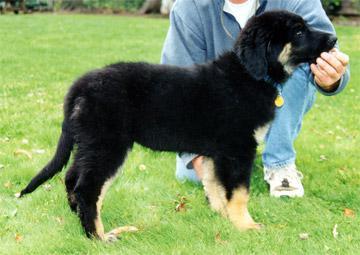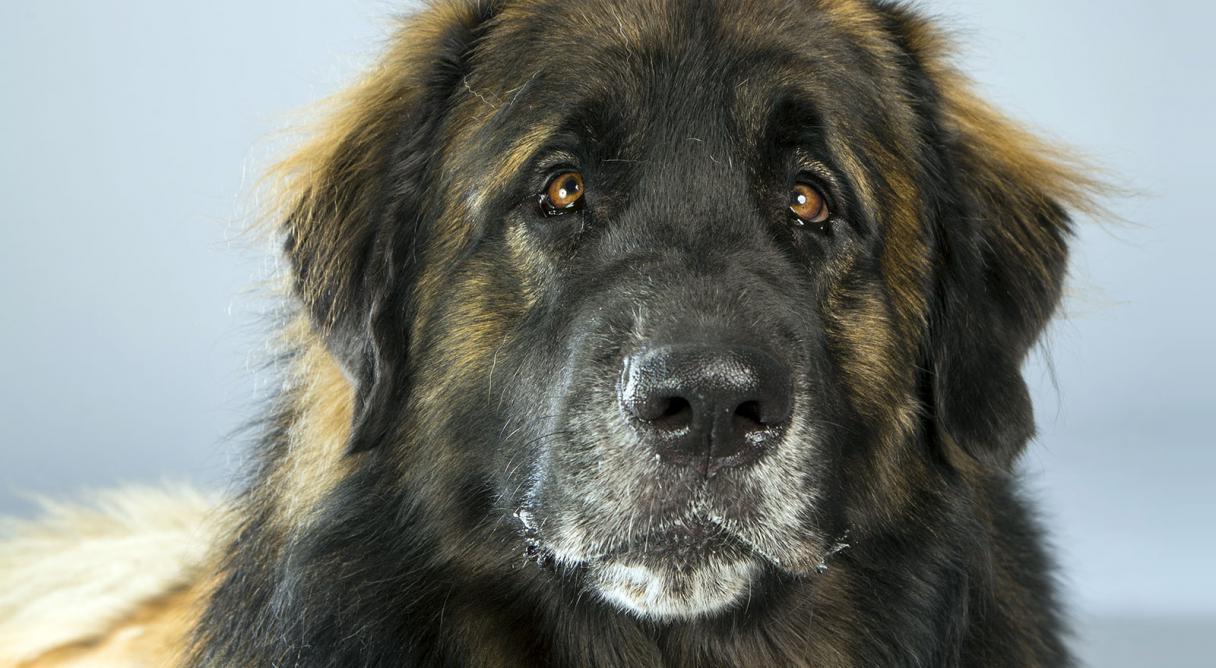The first image is the image on the left, the second image is the image on the right. Analyze the images presented: Is the assertion "Exactly one of the dogs is shown standing in profile on all fours in the grass." valid? Answer yes or no. Yes. The first image is the image on the left, the second image is the image on the right. For the images shown, is this caption "A dog is being touched by a human in one of the images." true? Answer yes or no. Yes. 